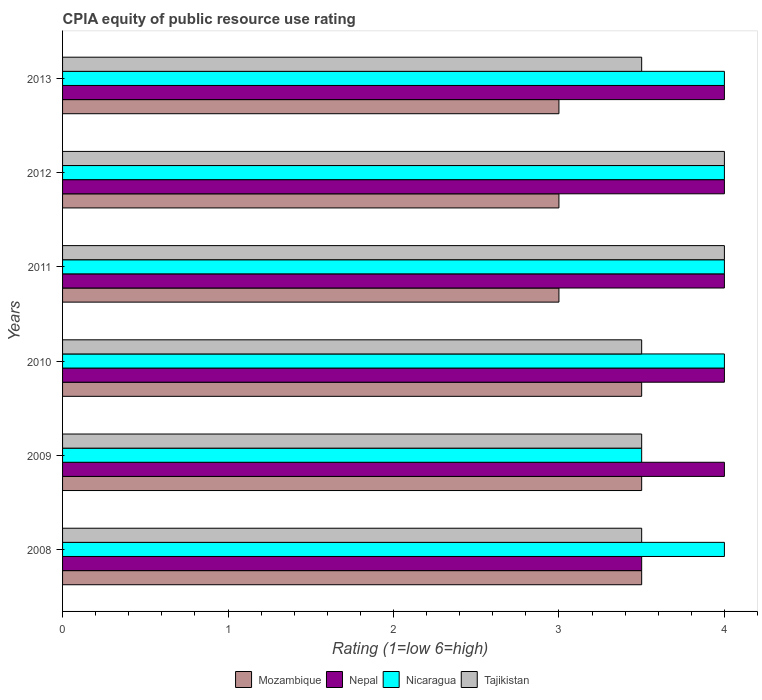How many different coloured bars are there?
Give a very brief answer. 4. Are the number of bars per tick equal to the number of legend labels?
Your answer should be compact. Yes. Are the number of bars on each tick of the Y-axis equal?
Offer a terse response. Yes. How many bars are there on the 6th tick from the bottom?
Your answer should be compact. 4. What is the label of the 6th group of bars from the top?
Your answer should be compact. 2008. What is the total CPIA rating in Mozambique in the graph?
Keep it short and to the point. 19.5. What is the difference between the CPIA rating in Tajikistan in 2010 and that in 2013?
Your answer should be very brief. 0. What is the difference between the CPIA rating in Tajikistan in 2011 and the CPIA rating in Mozambique in 2008?
Make the answer very short. 0.5. What is the average CPIA rating in Nicaragua per year?
Offer a very short reply. 3.92. Is the difference between the CPIA rating in Nicaragua in 2009 and 2013 greater than the difference between the CPIA rating in Tajikistan in 2009 and 2013?
Offer a very short reply. No. What is the difference between the highest and the second highest CPIA rating in Tajikistan?
Your response must be concise. 0. What is the difference between the highest and the lowest CPIA rating in Nicaragua?
Provide a short and direct response. 0.5. Is the sum of the CPIA rating in Nicaragua in 2008 and 2009 greater than the maximum CPIA rating in Mozambique across all years?
Provide a succinct answer. Yes. What does the 4th bar from the top in 2010 represents?
Provide a succinct answer. Mozambique. What does the 3rd bar from the bottom in 2012 represents?
Ensure brevity in your answer.  Nicaragua. Is it the case that in every year, the sum of the CPIA rating in Nepal and CPIA rating in Mozambique is greater than the CPIA rating in Nicaragua?
Provide a succinct answer. Yes. How many bars are there?
Provide a succinct answer. 24. How many years are there in the graph?
Give a very brief answer. 6. What is the difference between two consecutive major ticks on the X-axis?
Give a very brief answer. 1. Does the graph contain any zero values?
Make the answer very short. No. Does the graph contain grids?
Your response must be concise. No. How many legend labels are there?
Your response must be concise. 4. What is the title of the graph?
Provide a short and direct response. CPIA equity of public resource use rating. Does "Portugal" appear as one of the legend labels in the graph?
Offer a very short reply. No. What is the label or title of the X-axis?
Ensure brevity in your answer.  Rating (1=low 6=high). What is the label or title of the Y-axis?
Your answer should be compact. Years. What is the Rating (1=low 6=high) in Mozambique in 2008?
Offer a very short reply. 3.5. What is the Rating (1=low 6=high) in Nepal in 2008?
Make the answer very short. 3.5. What is the Rating (1=low 6=high) in Tajikistan in 2008?
Make the answer very short. 3.5. What is the Rating (1=low 6=high) in Nepal in 2009?
Your answer should be compact. 4. What is the Rating (1=low 6=high) in Nicaragua in 2009?
Your answer should be very brief. 3.5. What is the Rating (1=low 6=high) of Mozambique in 2010?
Keep it short and to the point. 3.5. What is the Rating (1=low 6=high) in Nepal in 2010?
Make the answer very short. 4. What is the Rating (1=low 6=high) in Nicaragua in 2010?
Provide a succinct answer. 4. What is the Rating (1=low 6=high) in Tajikistan in 2010?
Ensure brevity in your answer.  3.5. What is the Rating (1=low 6=high) of Nicaragua in 2011?
Provide a succinct answer. 4. What is the Rating (1=low 6=high) of Tajikistan in 2011?
Provide a short and direct response. 4. What is the Rating (1=low 6=high) of Nicaragua in 2012?
Offer a very short reply. 4. What is the Rating (1=low 6=high) of Nicaragua in 2013?
Give a very brief answer. 4. What is the Rating (1=low 6=high) of Tajikistan in 2013?
Keep it short and to the point. 3.5. Across all years, what is the maximum Rating (1=low 6=high) in Mozambique?
Give a very brief answer. 3.5. What is the total Rating (1=low 6=high) in Mozambique in the graph?
Offer a very short reply. 19.5. What is the total Rating (1=low 6=high) in Nepal in the graph?
Your answer should be compact. 23.5. What is the total Rating (1=low 6=high) of Tajikistan in the graph?
Offer a very short reply. 22. What is the difference between the Rating (1=low 6=high) of Mozambique in 2008 and that in 2009?
Offer a terse response. 0. What is the difference between the Rating (1=low 6=high) in Nepal in 2008 and that in 2009?
Keep it short and to the point. -0.5. What is the difference between the Rating (1=low 6=high) in Nicaragua in 2008 and that in 2009?
Offer a terse response. 0.5. What is the difference between the Rating (1=low 6=high) in Tajikistan in 2008 and that in 2010?
Your answer should be compact. 0. What is the difference between the Rating (1=low 6=high) of Nepal in 2008 and that in 2011?
Make the answer very short. -0.5. What is the difference between the Rating (1=low 6=high) in Nicaragua in 2008 and that in 2011?
Make the answer very short. 0. What is the difference between the Rating (1=low 6=high) in Tajikistan in 2008 and that in 2011?
Your response must be concise. -0.5. What is the difference between the Rating (1=low 6=high) in Mozambique in 2008 and that in 2012?
Provide a succinct answer. 0.5. What is the difference between the Rating (1=low 6=high) of Nepal in 2008 and that in 2012?
Offer a terse response. -0.5. What is the difference between the Rating (1=low 6=high) of Mozambique in 2008 and that in 2013?
Offer a terse response. 0.5. What is the difference between the Rating (1=low 6=high) in Nepal in 2008 and that in 2013?
Provide a short and direct response. -0.5. What is the difference between the Rating (1=low 6=high) of Tajikistan in 2008 and that in 2013?
Your response must be concise. 0. What is the difference between the Rating (1=low 6=high) of Mozambique in 2009 and that in 2010?
Provide a short and direct response. 0. What is the difference between the Rating (1=low 6=high) of Mozambique in 2009 and that in 2011?
Your response must be concise. 0.5. What is the difference between the Rating (1=low 6=high) of Tajikistan in 2009 and that in 2011?
Give a very brief answer. -0.5. What is the difference between the Rating (1=low 6=high) of Mozambique in 2009 and that in 2012?
Ensure brevity in your answer.  0.5. What is the difference between the Rating (1=low 6=high) in Mozambique in 2009 and that in 2013?
Provide a succinct answer. 0.5. What is the difference between the Rating (1=low 6=high) of Nicaragua in 2010 and that in 2011?
Provide a succinct answer. 0. What is the difference between the Rating (1=low 6=high) of Tajikistan in 2010 and that in 2011?
Offer a very short reply. -0.5. What is the difference between the Rating (1=low 6=high) in Mozambique in 2010 and that in 2012?
Provide a succinct answer. 0.5. What is the difference between the Rating (1=low 6=high) in Nicaragua in 2010 and that in 2012?
Provide a succinct answer. 0. What is the difference between the Rating (1=low 6=high) in Mozambique in 2010 and that in 2013?
Make the answer very short. 0.5. What is the difference between the Rating (1=low 6=high) of Tajikistan in 2010 and that in 2013?
Keep it short and to the point. 0. What is the difference between the Rating (1=low 6=high) of Mozambique in 2011 and that in 2012?
Keep it short and to the point. 0. What is the difference between the Rating (1=low 6=high) of Mozambique in 2011 and that in 2013?
Your response must be concise. 0. What is the difference between the Rating (1=low 6=high) of Tajikistan in 2011 and that in 2013?
Your answer should be compact. 0.5. What is the difference between the Rating (1=low 6=high) in Nicaragua in 2012 and that in 2013?
Provide a short and direct response. 0. What is the difference between the Rating (1=low 6=high) in Mozambique in 2008 and the Rating (1=low 6=high) in Nepal in 2009?
Give a very brief answer. -0.5. What is the difference between the Rating (1=low 6=high) in Mozambique in 2008 and the Rating (1=low 6=high) in Tajikistan in 2009?
Your answer should be very brief. 0. What is the difference between the Rating (1=low 6=high) in Nepal in 2008 and the Rating (1=low 6=high) in Tajikistan in 2009?
Give a very brief answer. 0. What is the difference between the Rating (1=low 6=high) in Mozambique in 2008 and the Rating (1=low 6=high) in Nepal in 2010?
Ensure brevity in your answer.  -0.5. What is the difference between the Rating (1=low 6=high) in Mozambique in 2008 and the Rating (1=low 6=high) in Tajikistan in 2010?
Give a very brief answer. 0. What is the difference between the Rating (1=low 6=high) of Nepal in 2008 and the Rating (1=low 6=high) of Nicaragua in 2010?
Give a very brief answer. -0.5. What is the difference between the Rating (1=low 6=high) in Nepal in 2008 and the Rating (1=low 6=high) in Tajikistan in 2010?
Offer a terse response. 0. What is the difference between the Rating (1=low 6=high) in Nicaragua in 2008 and the Rating (1=low 6=high) in Tajikistan in 2010?
Provide a short and direct response. 0.5. What is the difference between the Rating (1=low 6=high) of Mozambique in 2008 and the Rating (1=low 6=high) of Tajikistan in 2011?
Your answer should be very brief. -0.5. What is the difference between the Rating (1=low 6=high) in Nepal in 2008 and the Rating (1=low 6=high) in Nicaragua in 2011?
Your response must be concise. -0.5. What is the difference between the Rating (1=low 6=high) in Nepal in 2008 and the Rating (1=low 6=high) in Tajikistan in 2011?
Offer a very short reply. -0.5. What is the difference between the Rating (1=low 6=high) in Nicaragua in 2008 and the Rating (1=low 6=high) in Tajikistan in 2011?
Offer a very short reply. 0. What is the difference between the Rating (1=low 6=high) of Mozambique in 2008 and the Rating (1=low 6=high) of Nepal in 2012?
Offer a terse response. -0.5. What is the difference between the Rating (1=low 6=high) of Mozambique in 2008 and the Rating (1=low 6=high) of Nicaragua in 2012?
Provide a short and direct response. -0.5. What is the difference between the Rating (1=low 6=high) in Mozambique in 2008 and the Rating (1=low 6=high) in Tajikistan in 2012?
Provide a short and direct response. -0.5. What is the difference between the Rating (1=low 6=high) of Nepal in 2008 and the Rating (1=low 6=high) of Nicaragua in 2012?
Ensure brevity in your answer.  -0.5. What is the difference between the Rating (1=low 6=high) in Nepal in 2008 and the Rating (1=low 6=high) in Tajikistan in 2012?
Ensure brevity in your answer.  -0.5. What is the difference between the Rating (1=low 6=high) in Nepal in 2008 and the Rating (1=low 6=high) in Nicaragua in 2013?
Provide a succinct answer. -0.5. What is the difference between the Rating (1=low 6=high) in Nepal in 2008 and the Rating (1=low 6=high) in Tajikistan in 2013?
Give a very brief answer. 0. What is the difference between the Rating (1=low 6=high) in Nicaragua in 2008 and the Rating (1=low 6=high) in Tajikistan in 2013?
Offer a very short reply. 0.5. What is the difference between the Rating (1=low 6=high) in Nepal in 2009 and the Rating (1=low 6=high) in Nicaragua in 2010?
Your answer should be very brief. 0. What is the difference between the Rating (1=low 6=high) of Nepal in 2009 and the Rating (1=low 6=high) of Tajikistan in 2010?
Provide a short and direct response. 0.5. What is the difference between the Rating (1=low 6=high) in Mozambique in 2009 and the Rating (1=low 6=high) in Nicaragua in 2011?
Make the answer very short. -0.5. What is the difference between the Rating (1=low 6=high) in Mozambique in 2009 and the Rating (1=low 6=high) in Tajikistan in 2011?
Offer a terse response. -0.5. What is the difference between the Rating (1=low 6=high) in Nepal in 2009 and the Rating (1=low 6=high) in Nicaragua in 2011?
Keep it short and to the point. 0. What is the difference between the Rating (1=low 6=high) in Nepal in 2009 and the Rating (1=low 6=high) in Tajikistan in 2011?
Give a very brief answer. 0. What is the difference between the Rating (1=low 6=high) in Nicaragua in 2009 and the Rating (1=low 6=high) in Tajikistan in 2011?
Your answer should be very brief. -0.5. What is the difference between the Rating (1=low 6=high) in Mozambique in 2009 and the Rating (1=low 6=high) in Nicaragua in 2012?
Keep it short and to the point. -0.5. What is the difference between the Rating (1=low 6=high) in Nepal in 2009 and the Rating (1=low 6=high) in Nicaragua in 2012?
Ensure brevity in your answer.  0. What is the difference between the Rating (1=low 6=high) in Nepal in 2009 and the Rating (1=low 6=high) in Tajikistan in 2012?
Your response must be concise. 0. What is the difference between the Rating (1=low 6=high) of Nicaragua in 2009 and the Rating (1=low 6=high) of Tajikistan in 2012?
Keep it short and to the point. -0.5. What is the difference between the Rating (1=low 6=high) of Mozambique in 2009 and the Rating (1=low 6=high) of Nepal in 2013?
Provide a succinct answer. -0.5. What is the difference between the Rating (1=low 6=high) in Nepal in 2009 and the Rating (1=low 6=high) in Nicaragua in 2013?
Keep it short and to the point. 0. What is the difference between the Rating (1=low 6=high) in Mozambique in 2010 and the Rating (1=low 6=high) in Nepal in 2011?
Your response must be concise. -0.5. What is the difference between the Rating (1=low 6=high) of Mozambique in 2010 and the Rating (1=low 6=high) of Nicaragua in 2011?
Make the answer very short. -0.5. What is the difference between the Rating (1=low 6=high) in Mozambique in 2010 and the Rating (1=low 6=high) in Tajikistan in 2011?
Make the answer very short. -0.5. What is the difference between the Rating (1=low 6=high) in Nepal in 2010 and the Rating (1=low 6=high) in Nicaragua in 2011?
Make the answer very short. 0. What is the difference between the Rating (1=low 6=high) of Nepal in 2010 and the Rating (1=low 6=high) of Tajikistan in 2011?
Ensure brevity in your answer.  0. What is the difference between the Rating (1=low 6=high) in Nicaragua in 2010 and the Rating (1=low 6=high) in Tajikistan in 2011?
Keep it short and to the point. 0. What is the difference between the Rating (1=low 6=high) in Mozambique in 2010 and the Rating (1=low 6=high) in Nicaragua in 2012?
Provide a succinct answer. -0.5. What is the difference between the Rating (1=low 6=high) of Nepal in 2010 and the Rating (1=low 6=high) of Nicaragua in 2012?
Your answer should be very brief. 0. What is the difference between the Rating (1=low 6=high) in Nepal in 2010 and the Rating (1=low 6=high) in Tajikistan in 2012?
Your answer should be compact. 0. What is the difference between the Rating (1=low 6=high) of Nicaragua in 2010 and the Rating (1=low 6=high) of Tajikistan in 2012?
Make the answer very short. 0. What is the difference between the Rating (1=low 6=high) in Mozambique in 2010 and the Rating (1=low 6=high) in Nepal in 2013?
Your response must be concise. -0.5. What is the difference between the Rating (1=low 6=high) of Nepal in 2010 and the Rating (1=low 6=high) of Nicaragua in 2013?
Offer a terse response. 0. What is the difference between the Rating (1=low 6=high) in Nepal in 2010 and the Rating (1=low 6=high) in Tajikistan in 2013?
Your response must be concise. 0.5. What is the difference between the Rating (1=low 6=high) of Nicaragua in 2010 and the Rating (1=low 6=high) of Tajikistan in 2013?
Your response must be concise. 0.5. What is the difference between the Rating (1=low 6=high) in Mozambique in 2011 and the Rating (1=low 6=high) in Nepal in 2012?
Your answer should be compact. -1. What is the difference between the Rating (1=low 6=high) of Nicaragua in 2011 and the Rating (1=low 6=high) of Tajikistan in 2013?
Make the answer very short. 0.5. What is the difference between the Rating (1=low 6=high) in Mozambique in 2012 and the Rating (1=low 6=high) in Tajikistan in 2013?
Offer a very short reply. -0.5. What is the difference between the Rating (1=low 6=high) of Nepal in 2012 and the Rating (1=low 6=high) of Nicaragua in 2013?
Your answer should be compact. 0. What is the difference between the Rating (1=low 6=high) of Nepal in 2012 and the Rating (1=low 6=high) of Tajikistan in 2013?
Provide a succinct answer. 0.5. What is the difference between the Rating (1=low 6=high) of Nicaragua in 2012 and the Rating (1=low 6=high) of Tajikistan in 2013?
Your answer should be compact. 0.5. What is the average Rating (1=low 6=high) of Nepal per year?
Provide a succinct answer. 3.92. What is the average Rating (1=low 6=high) in Nicaragua per year?
Make the answer very short. 3.92. What is the average Rating (1=low 6=high) of Tajikistan per year?
Offer a terse response. 3.67. In the year 2008, what is the difference between the Rating (1=low 6=high) of Mozambique and Rating (1=low 6=high) of Nepal?
Make the answer very short. 0. In the year 2008, what is the difference between the Rating (1=low 6=high) of Nepal and Rating (1=low 6=high) of Nicaragua?
Offer a very short reply. -0.5. In the year 2008, what is the difference between the Rating (1=low 6=high) of Nicaragua and Rating (1=low 6=high) of Tajikistan?
Your answer should be very brief. 0.5. In the year 2009, what is the difference between the Rating (1=low 6=high) in Mozambique and Rating (1=low 6=high) in Tajikistan?
Your response must be concise. 0. In the year 2010, what is the difference between the Rating (1=low 6=high) in Mozambique and Rating (1=low 6=high) in Nicaragua?
Give a very brief answer. -0.5. In the year 2010, what is the difference between the Rating (1=low 6=high) of Mozambique and Rating (1=low 6=high) of Tajikistan?
Offer a terse response. 0. In the year 2010, what is the difference between the Rating (1=low 6=high) of Nepal and Rating (1=low 6=high) of Nicaragua?
Provide a succinct answer. 0. In the year 2010, what is the difference between the Rating (1=low 6=high) of Nepal and Rating (1=low 6=high) of Tajikistan?
Your answer should be very brief. 0.5. In the year 2011, what is the difference between the Rating (1=low 6=high) in Mozambique and Rating (1=low 6=high) in Nicaragua?
Your response must be concise. -1. In the year 2011, what is the difference between the Rating (1=low 6=high) in Mozambique and Rating (1=low 6=high) in Tajikistan?
Provide a succinct answer. -1. In the year 2011, what is the difference between the Rating (1=low 6=high) of Nepal and Rating (1=low 6=high) of Tajikistan?
Make the answer very short. 0. In the year 2011, what is the difference between the Rating (1=low 6=high) in Nicaragua and Rating (1=low 6=high) in Tajikistan?
Ensure brevity in your answer.  0. In the year 2012, what is the difference between the Rating (1=low 6=high) of Mozambique and Rating (1=low 6=high) of Tajikistan?
Your answer should be compact. -1. In the year 2012, what is the difference between the Rating (1=low 6=high) of Nicaragua and Rating (1=low 6=high) of Tajikistan?
Your answer should be very brief. 0. In the year 2013, what is the difference between the Rating (1=low 6=high) in Nepal and Rating (1=low 6=high) in Nicaragua?
Give a very brief answer. 0. In the year 2013, what is the difference between the Rating (1=low 6=high) in Nicaragua and Rating (1=low 6=high) in Tajikistan?
Keep it short and to the point. 0.5. What is the ratio of the Rating (1=low 6=high) in Mozambique in 2008 to that in 2009?
Provide a short and direct response. 1. What is the ratio of the Rating (1=low 6=high) of Nepal in 2008 to that in 2009?
Your response must be concise. 0.88. What is the ratio of the Rating (1=low 6=high) in Nicaragua in 2008 to that in 2009?
Offer a very short reply. 1.14. What is the ratio of the Rating (1=low 6=high) in Tajikistan in 2008 to that in 2009?
Your answer should be compact. 1. What is the ratio of the Rating (1=low 6=high) in Mozambique in 2008 to that in 2010?
Provide a succinct answer. 1. What is the ratio of the Rating (1=low 6=high) in Nepal in 2008 to that in 2010?
Give a very brief answer. 0.88. What is the ratio of the Rating (1=low 6=high) in Nicaragua in 2008 to that in 2011?
Keep it short and to the point. 1. What is the ratio of the Rating (1=low 6=high) in Nepal in 2008 to that in 2012?
Your response must be concise. 0.88. What is the ratio of the Rating (1=low 6=high) of Nicaragua in 2008 to that in 2012?
Your response must be concise. 1. What is the ratio of the Rating (1=low 6=high) in Nicaragua in 2008 to that in 2013?
Give a very brief answer. 1. What is the ratio of the Rating (1=low 6=high) of Mozambique in 2009 to that in 2010?
Offer a terse response. 1. What is the ratio of the Rating (1=low 6=high) of Tajikistan in 2009 to that in 2010?
Provide a short and direct response. 1. What is the ratio of the Rating (1=low 6=high) in Nicaragua in 2009 to that in 2011?
Give a very brief answer. 0.88. What is the ratio of the Rating (1=low 6=high) in Nepal in 2009 to that in 2012?
Your response must be concise. 1. What is the ratio of the Rating (1=low 6=high) of Tajikistan in 2009 to that in 2012?
Your answer should be very brief. 0.88. What is the ratio of the Rating (1=low 6=high) in Nepal in 2009 to that in 2013?
Your response must be concise. 1. What is the ratio of the Rating (1=low 6=high) in Nicaragua in 2009 to that in 2013?
Offer a terse response. 0.88. What is the ratio of the Rating (1=low 6=high) in Tajikistan in 2009 to that in 2013?
Your answer should be compact. 1. What is the ratio of the Rating (1=low 6=high) of Nepal in 2010 to that in 2012?
Keep it short and to the point. 1. What is the ratio of the Rating (1=low 6=high) in Tajikistan in 2010 to that in 2012?
Ensure brevity in your answer.  0.88. What is the ratio of the Rating (1=low 6=high) of Nepal in 2010 to that in 2013?
Keep it short and to the point. 1. What is the ratio of the Rating (1=low 6=high) in Mozambique in 2011 to that in 2012?
Offer a very short reply. 1. What is the ratio of the Rating (1=low 6=high) of Nepal in 2011 to that in 2012?
Keep it short and to the point. 1. What is the ratio of the Rating (1=low 6=high) of Tajikistan in 2011 to that in 2012?
Your answer should be very brief. 1. What is the ratio of the Rating (1=low 6=high) of Mozambique in 2011 to that in 2013?
Offer a terse response. 1. What is the ratio of the Rating (1=low 6=high) of Nepal in 2011 to that in 2013?
Offer a terse response. 1. What is the ratio of the Rating (1=low 6=high) in Nicaragua in 2011 to that in 2013?
Your answer should be compact. 1. What is the ratio of the Rating (1=low 6=high) of Mozambique in 2012 to that in 2013?
Give a very brief answer. 1. What is the ratio of the Rating (1=low 6=high) in Nepal in 2012 to that in 2013?
Provide a succinct answer. 1. What is the difference between the highest and the second highest Rating (1=low 6=high) of Mozambique?
Your answer should be compact. 0. What is the difference between the highest and the second highest Rating (1=low 6=high) of Nepal?
Provide a short and direct response. 0. What is the difference between the highest and the second highest Rating (1=low 6=high) of Nicaragua?
Your answer should be compact. 0. What is the difference between the highest and the lowest Rating (1=low 6=high) in Mozambique?
Make the answer very short. 0.5. What is the difference between the highest and the lowest Rating (1=low 6=high) in Tajikistan?
Offer a very short reply. 0.5. 